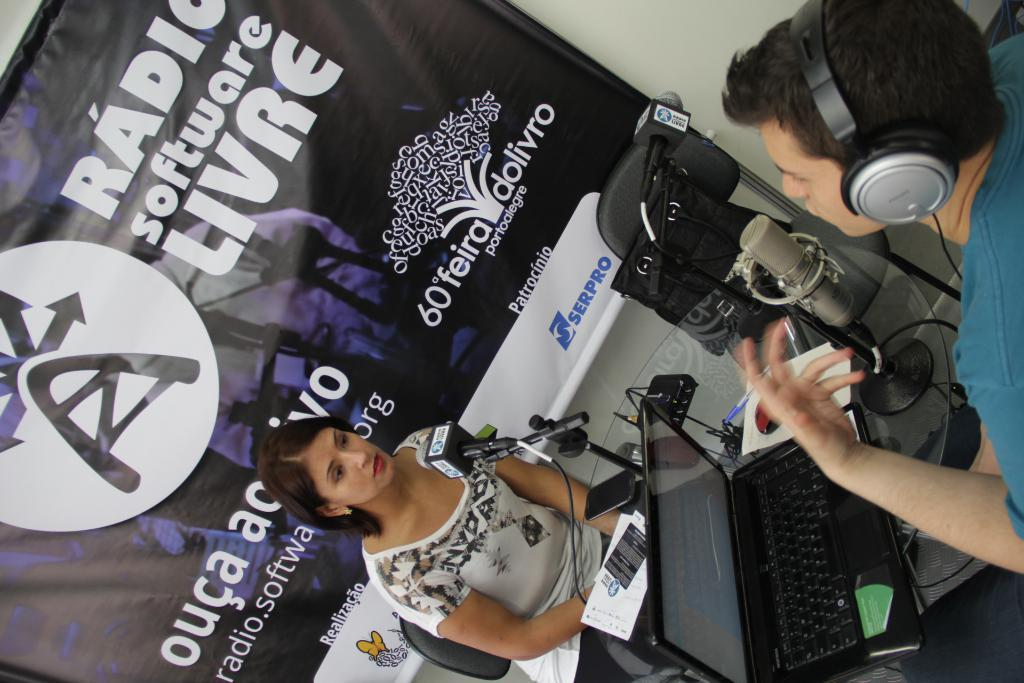<image>
Render a clear and concise summary of the photo. WOman giving an interview in front of a banner that says "ouca" in the beginning. 